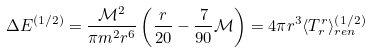<formula> <loc_0><loc_0><loc_500><loc_500>\Delta E ^ { \left ( 1 / 2 \right ) } = \frac { \mathcal { M } ^ { 2 } } { \pi m ^ { 2 } r ^ { 6 } } \left ( \frac { r } { 2 0 } - \frac { 7 } { 9 0 } \mathcal { M } \right ) = 4 \pi r ^ { 3 } \langle T _ { r } ^ { r } \rangle _ { r e n } ^ { \left ( 1 / 2 \right ) }</formula> 